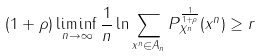<formula> <loc_0><loc_0><loc_500><loc_500>( 1 + \rho ) \liminf _ { n \rightarrow \infty } \frac { 1 } { n } \ln \sum _ { x ^ { n } \in A _ { n } } P _ { X ^ { n } } ^ { \frac { 1 } { 1 + \rho } } ( x ^ { n } ) \geq r</formula> 